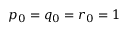Convert formula to latex. <formula><loc_0><loc_0><loc_500><loc_500>p _ { 0 } = q _ { 0 } = r _ { 0 } = 1</formula> 